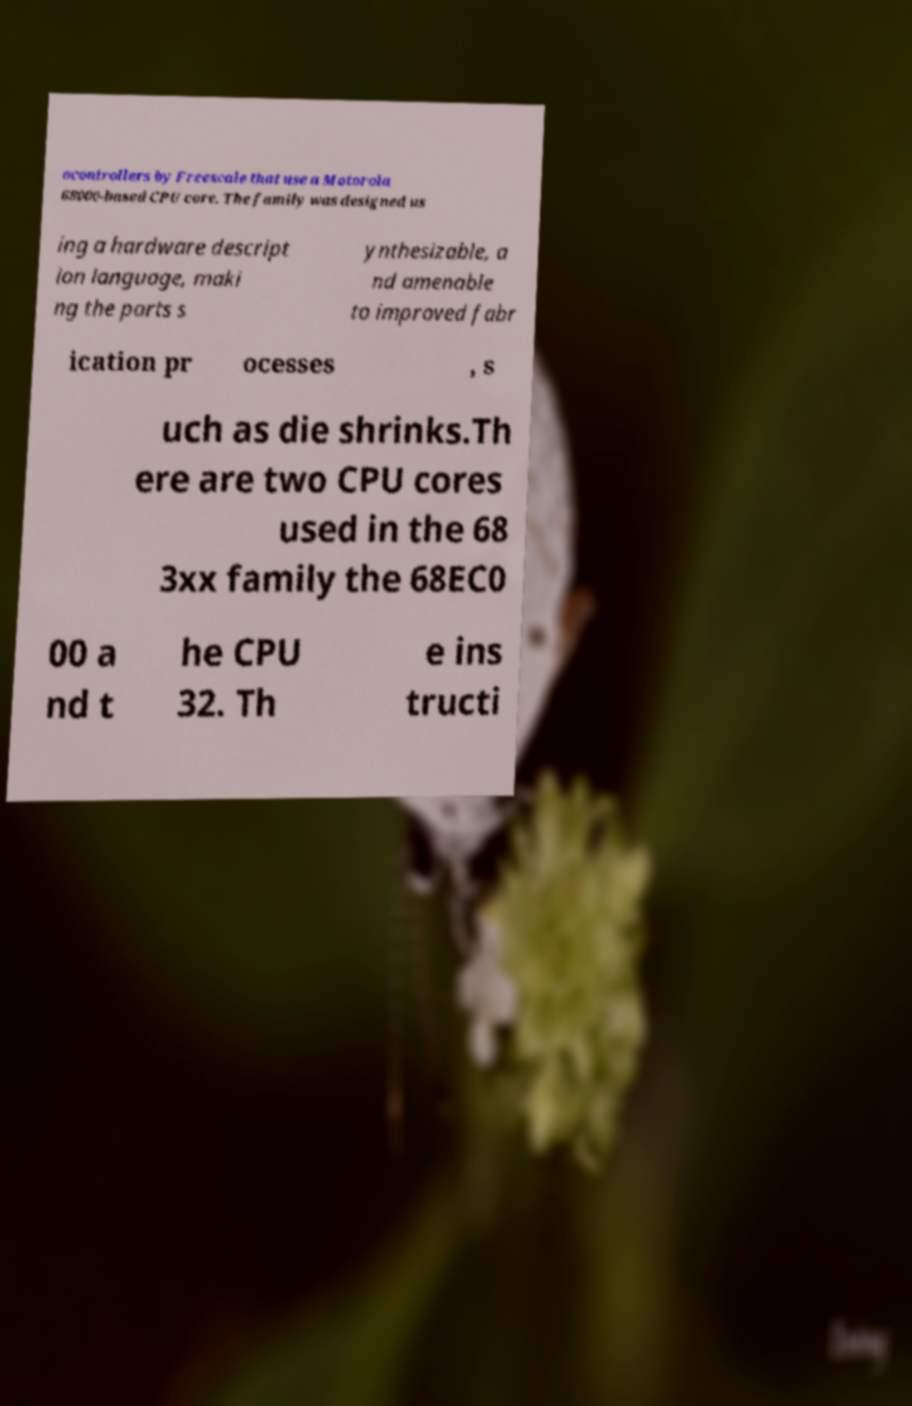Can you accurately transcribe the text from the provided image for me? ocontrollers by Freescale that use a Motorola 68000-based CPU core. The family was designed us ing a hardware descript ion language, maki ng the parts s ynthesizable, a nd amenable to improved fabr ication pr ocesses , s uch as die shrinks.Th ere are two CPU cores used in the 68 3xx family the 68EC0 00 a nd t he CPU 32. Th e ins tructi 